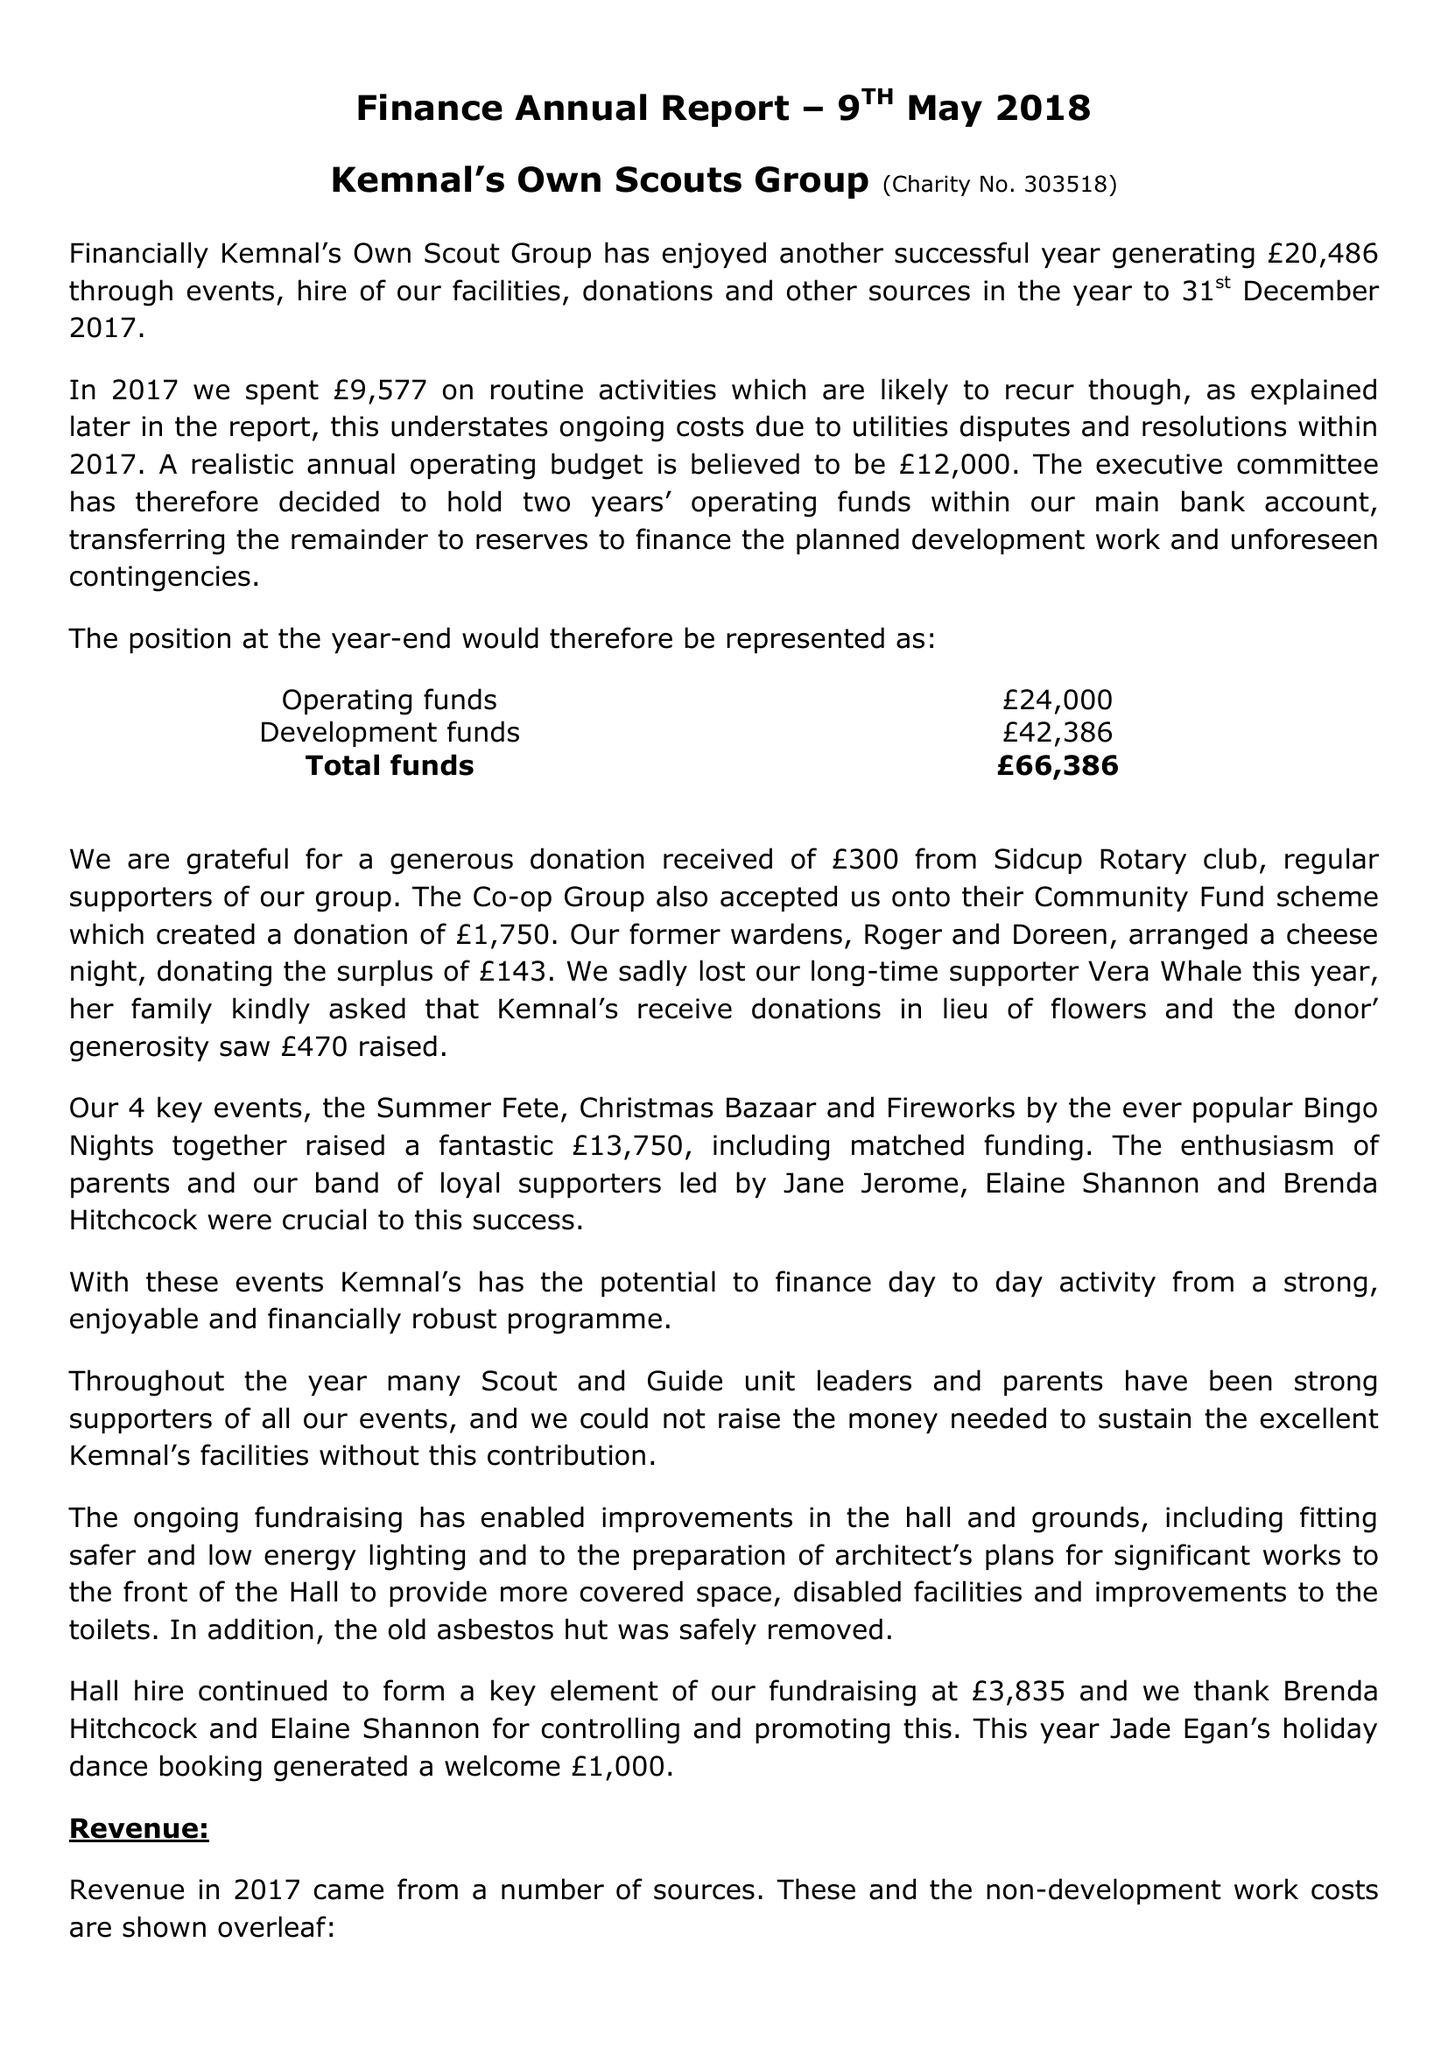What is the value for the address__post_town?
Answer the question using a single word or phrase. SIDCUP 